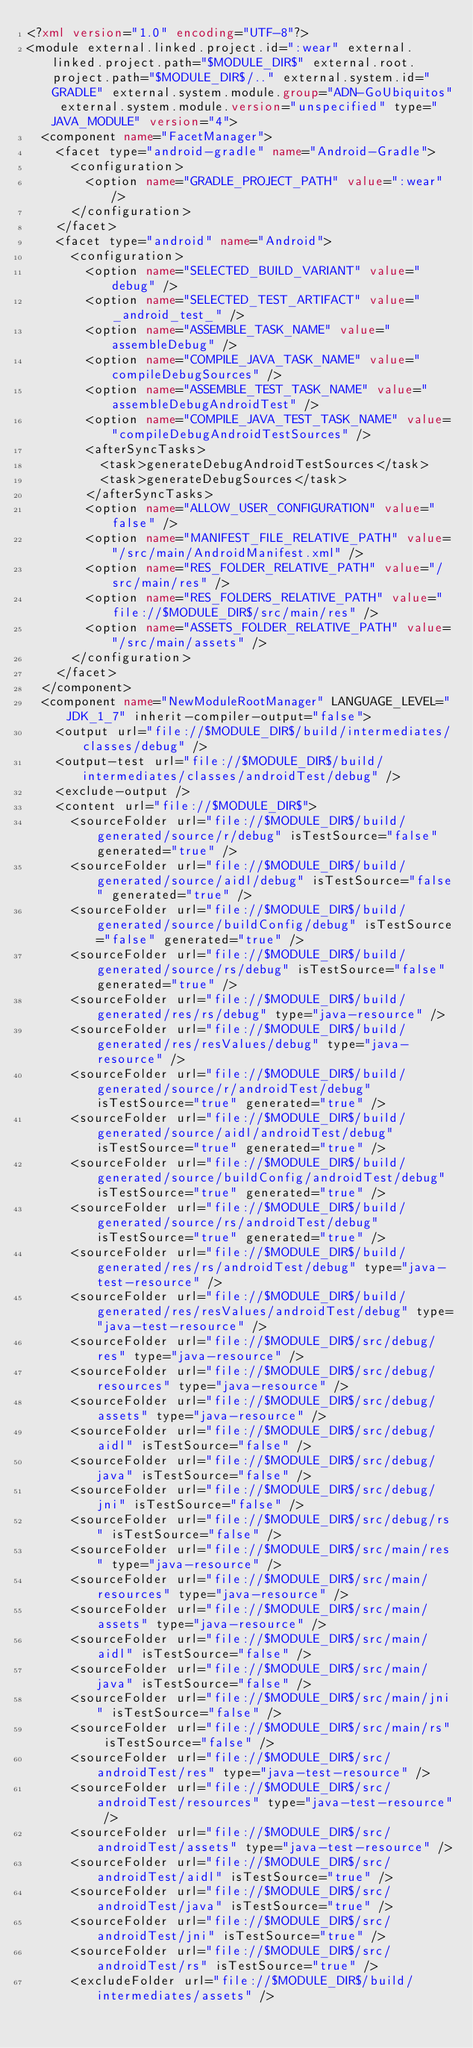<code> <loc_0><loc_0><loc_500><loc_500><_XML_><?xml version="1.0" encoding="UTF-8"?>
<module external.linked.project.id=":wear" external.linked.project.path="$MODULE_DIR$" external.root.project.path="$MODULE_DIR$/.." external.system.id="GRADLE" external.system.module.group="ADN-GoUbiquitos" external.system.module.version="unspecified" type="JAVA_MODULE" version="4">
  <component name="FacetManager">
    <facet type="android-gradle" name="Android-Gradle">
      <configuration>
        <option name="GRADLE_PROJECT_PATH" value=":wear" />
      </configuration>
    </facet>
    <facet type="android" name="Android">
      <configuration>
        <option name="SELECTED_BUILD_VARIANT" value="debug" />
        <option name="SELECTED_TEST_ARTIFACT" value="_android_test_" />
        <option name="ASSEMBLE_TASK_NAME" value="assembleDebug" />
        <option name="COMPILE_JAVA_TASK_NAME" value="compileDebugSources" />
        <option name="ASSEMBLE_TEST_TASK_NAME" value="assembleDebugAndroidTest" />
        <option name="COMPILE_JAVA_TEST_TASK_NAME" value="compileDebugAndroidTestSources" />
        <afterSyncTasks>
          <task>generateDebugAndroidTestSources</task>
          <task>generateDebugSources</task>
        </afterSyncTasks>
        <option name="ALLOW_USER_CONFIGURATION" value="false" />
        <option name="MANIFEST_FILE_RELATIVE_PATH" value="/src/main/AndroidManifest.xml" />
        <option name="RES_FOLDER_RELATIVE_PATH" value="/src/main/res" />
        <option name="RES_FOLDERS_RELATIVE_PATH" value="file://$MODULE_DIR$/src/main/res" />
        <option name="ASSETS_FOLDER_RELATIVE_PATH" value="/src/main/assets" />
      </configuration>
    </facet>
  </component>
  <component name="NewModuleRootManager" LANGUAGE_LEVEL="JDK_1_7" inherit-compiler-output="false">
    <output url="file://$MODULE_DIR$/build/intermediates/classes/debug" />
    <output-test url="file://$MODULE_DIR$/build/intermediates/classes/androidTest/debug" />
    <exclude-output />
    <content url="file://$MODULE_DIR$">
      <sourceFolder url="file://$MODULE_DIR$/build/generated/source/r/debug" isTestSource="false" generated="true" />
      <sourceFolder url="file://$MODULE_DIR$/build/generated/source/aidl/debug" isTestSource="false" generated="true" />
      <sourceFolder url="file://$MODULE_DIR$/build/generated/source/buildConfig/debug" isTestSource="false" generated="true" />
      <sourceFolder url="file://$MODULE_DIR$/build/generated/source/rs/debug" isTestSource="false" generated="true" />
      <sourceFolder url="file://$MODULE_DIR$/build/generated/res/rs/debug" type="java-resource" />
      <sourceFolder url="file://$MODULE_DIR$/build/generated/res/resValues/debug" type="java-resource" />
      <sourceFolder url="file://$MODULE_DIR$/build/generated/source/r/androidTest/debug" isTestSource="true" generated="true" />
      <sourceFolder url="file://$MODULE_DIR$/build/generated/source/aidl/androidTest/debug" isTestSource="true" generated="true" />
      <sourceFolder url="file://$MODULE_DIR$/build/generated/source/buildConfig/androidTest/debug" isTestSource="true" generated="true" />
      <sourceFolder url="file://$MODULE_DIR$/build/generated/source/rs/androidTest/debug" isTestSource="true" generated="true" />
      <sourceFolder url="file://$MODULE_DIR$/build/generated/res/rs/androidTest/debug" type="java-test-resource" />
      <sourceFolder url="file://$MODULE_DIR$/build/generated/res/resValues/androidTest/debug" type="java-test-resource" />
      <sourceFolder url="file://$MODULE_DIR$/src/debug/res" type="java-resource" />
      <sourceFolder url="file://$MODULE_DIR$/src/debug/resources" type="java-resource" />
      <sourceFolder url="file://$MODULE_DIR$/src/debug/assets" type="java-resource" />
      <sourceFolder url="file://$MODULE_DIR$/src/debug/aidl" isTestSource="false" />
      <sourceFolder url="file://$MODULE_DIR$/src/debug/java" isTestSource="false" />
      <sourceFolder url="file://$MODULE_DIR$/src/debug/jni" isTestSource="false" />
      <sourceFolder url="file://$MODULE_DIR$/src/debug/rs" isTestSource="false" />
      <sourceFolder url="file://$MODULE_DIR$/src/main/res" type="java-resource" />
      <sourceFolder url="file://$MODULE_DIR$/src/main/resources" type="java-resource" />
      <sourceFolder url="file://$MODULE_DIR$/src/main/assets" type="java-resource" />
      <sourceFolder url="file://$MODULE_DIR$/src/main/aidl" isTestSource="false" />
      <sourceFolder url="file://$MODULE_DIR$/src/main/java" isTestSource="false" />
      <sourceFolder url="file://$MODULE_DIR$/src/main/jni" isTestSource="false" />
      <sourceFolder url="file://$MODULE_DIR$/src/main/rs" isTestSource="false" />
      <sourceFolder url="file://$MODULE_DIR$/src/androidTest/res" type="java-test-resource" />
      <sourceFolder url="file://$MODULE_DIR$/src/androidTest/resources" type="java-test-resource" />
      <sourceFolder url="file://$MODULE_DIR$/src/androidTest/assets" type="java-test-resource" />
      <sourceFolder url="file://$MODULE_DIR$/src/androidTest/aidl" isTestSource="true" />
      <sourceFolder url="file://$MODULE_DIR$/src/androidTest/java" isTestSource="true" />
      <sourceFolder url="file://$MODULE_DIR$/src/androidTest/jni" isTestSource="true" />
      <sourceFolder url="file://$MODULE_DIR$/src/androidTest/rs" isTestSource="true" />
      <excludeFolder url="file://$MODULE_DIR$/build/intermediates/assets" /></code> 